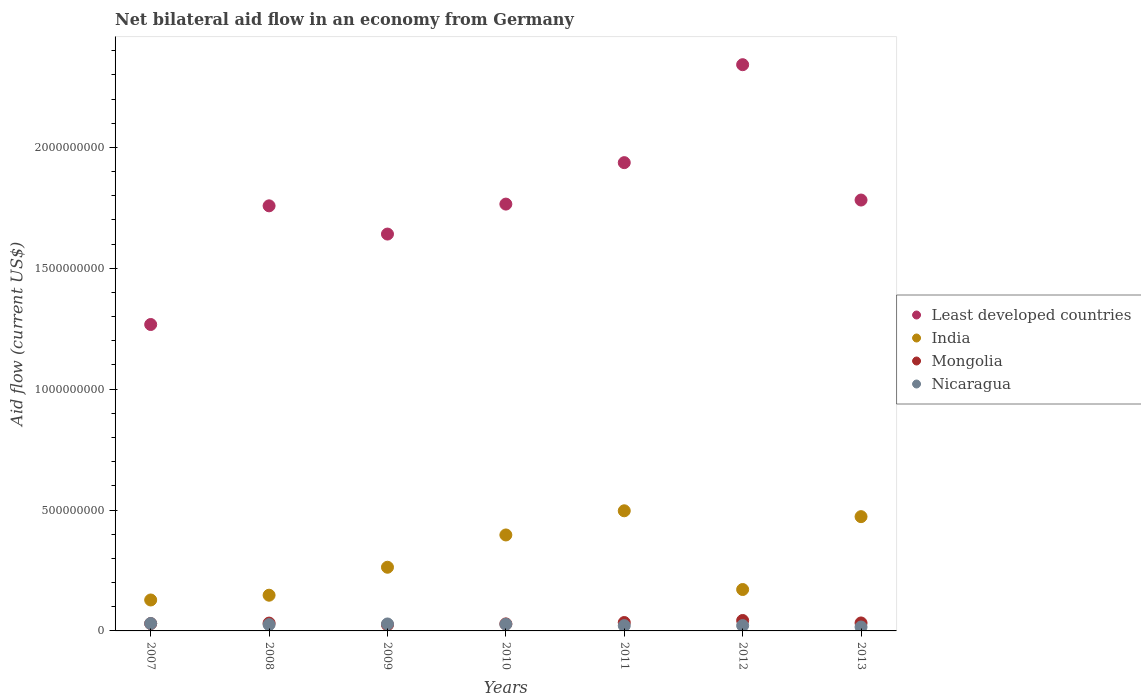How many different coloured dotlines are there?
Make the answer very short. 4. What is the net bilateral aid flow in India in 2010?
Provide a short and direct response. 3.97e+08. Across all years, what is the maximum net bilateral aid flow in India?
Provide a short and direct response. 4.97e+08. Across all years, what is the minimum net bilateral aid flow in Least developed countries?
Keep it short and to the point. 1.27e+09. In which year was the net bilateral aid flow in India minimum?
Ensure brevity in your answer.  2007. What is the total net bilateral aid flow in Mongolia in the graph?
Provide a succinct answer. 2.28e+08. What is the difference between the net bilateral aid flow in India in 2009 and that in 2012?
Offer a terse response. 9.21e+07. What is the difference between the net bilateral aid flow in India in 2010 and the net bilateral aid flow in Mongolia in 2007?
Your answer should be very brief. 3.67e+08. What is the average net bilateral aid flow in Nicaragua per year?
Keep it short and to the point. 2.48e+07. In the year 2013, what is the difference between the net bilateral aid flow in India and net bilateral aid flow in Mongolia?
Your response must be concise. 4.40e+08. What is the ratio of the net bilateral aid flow in Mongolia in 2010 to that in 2011?
Provide a succinct answer. 0.84. Is the net bilateral aid flow in India in 2008 less than that in 2009?
Offer a terse response. Yes. What is the difference between the highest and the second highest net bilateral aid flow in Least developed countries?
Offer a very short reply. 4.05e+08. What is the difference between the highest and the lowest net bilateral aid flow in Least developed countries?
Offer a very short reply. 1.07e+09. In how many years, is the net bilateral aid flow in Mongolia greater than the average net bilateral aid flow in Mongolia taken over all years?
Make the answer very short. 3. Is the sum of the net bilateral aid flow in India in 2007 and 2010 greater than the maximum net bilateral aid flow in Mongolia across all years?
Ensure brevity in your answer.  Yes. Is it the case that in every year, the sum of the net bilateral aid flow in Nicaragua and net bilateral aid flow in Mongolia  is greater than the sum of net bilateral aid flow in India and net bilateral aid flow in Least developed countries?
Provide a short and direct response. No. Is it the case that in every year, the sum of the net bilateral aid flow in India and net bilateral aid flow in Mongolia  is greater than the net bilateral aid flow in Nicaragua?
Make the answer very short. Yes. Is the net bilateral aid flow in India strictly less than the net bilateral aid flow in Nicaragua over the years?
Your answer should be very brief. No. How many dotlines are there?
Your response must be concise. 4. How many years are there in the graph?
Provide a short and direct response. 7. Are the values on the major ticks of Y-axis written in scientific E-notation?
Your response must be concise. No. Does the graph contain any zero values?
Offer a terse response. No. Does the graph contain grids?
Provide a succinct answer. No. How many legend labels are there?
Provide a short and direct response. 4. How are the legend labels stacked?
Your answer should be compact. Vertical. What is the title of the graph?
Keep it short and to the point. Net bilateral aid flow in an economy from Germany. Does "Vanuatu" appear as one of the legend labels in the graph?
Offer a very short reply. No. What is the label or title of the X-axis?
Offer a very short reply. Years. What is the label or title of the Y-axis?
Your response must be concise. Aid flow (current US$). What is the Aid flow (current US$) in Least developed countries in 2007?
Provide a succinct answer. 1.27e+09. What is the Aid flow (current US$) in India in 2007?
Give a very brief answer. 1.28e+08. What is the Aid flow (current US$) in Mongolia in 2007?
Offer a terse response. 3.03e+07. What is the Aid flow (current US$) in Nicaragua in 2007?
Your answer should be very brief. 3.08e+07. What is the Aid flow (current US$) in Least developed countries in 2008?
Ensure brevity in your answer.  1.76e+09. What is the Aid flow (current US$) of India in 2008?
Make the answer very short. 1.48e+08. What is the Aid flow (current US$) of Mongolia in 2008?
Your answer should be compact. 3.24e+07. What is the Aid flow (current US$) in Nicaragua in 2008?
Keep it short and to the point. 2.61e+07. What is the Aid flow (current US$) of Least developed countries in 2009?
Your answer should be compact. 1.64e+09. What is the Aid flow (current US$) in India in 2009?
Give a very brief answer. 2.63e+08. What is the Aid flow (current US$) in Mongolia in 2009?
Offer a very short reply. 2.54e+07. What is the Aid flow (current US$) in Nicaragua in 2009?
Your answer should be compact. 2.88e+07. What is the Aid flow (current US$) in Least developed countries in 2010?
Make the answer very short. 1.77e+09. What is the Aid flow (current US$) of India in 2010?
Offer a very short reply. 3.97e+08. What is the Aid flow (current US$) in Mongolia in 2010?
Your answer should be compact. 2.91e+07. What is the Aid flow (current US$) of Nicaragua in 2010?
Your answer should be compact. 2.77e+07. What is the Aid flow (current US$) in Least developed countries in 2011?
Provide a short and direct response. 1.94e+09. What is the Aid flow (current US$) in India in 2011?
Provide a succinct answer. 4.97e+08. What is the Aid flow (current US$) of Mongolia in 2011?
Your response must be concise. 3.47e+07. What is the Aid flow (current US$) in Nicaragua in 2011?
Provide a succinct answer. 2.18e+07. What is the Aid flow (current US$) of Least developed countries in 2012?
Give a very brief answer. 2.34e+09. What is the Aid flow (current US$) in India in 2012?
Keep it short and to the point. 1.71e+08. What is the Aid flow (current US$) of Mongolia in 2012?
Provide a short and direct response. 4.31e+07. What is the Aid flow (current US$) in Nicaragua in 2012?
Your answer should be very brief. 2.21e+07. What is the Aid flow (current US$) of Least developed countries in 2013?
Your answer should be very brief. 1.78e+09. What is the Aid flow (current US$) of India in 2013?
Ensure brevity in your answer.  4.73e+08. What is the Aid flow (current US$) in Mongolia in 2013?
Ensure brevity in your answer.  3.29e+07. What is the Aid flow (current US$) in Nicaragua in 2013?
Provide a succinct answer. 1.62e+07. Across all years, what is the maximum Aid flow (current US$) in Least developed countries?
Offer a very short reply. 2.34e+09. Across all years, what is the maximum Aid flow (current US$) of India?
Your answer should be compact. 4.97e+08. Across all years, what is the maximum Aid flow (current US$) in Mongolia?
Keep it short and to the point. 4.31e+07. Across all years, what is the maximum Aid flow (current US$) of Nicaragua?
Your response must be concise. 3.08e+07. Across all years, what is the minimum Aid flow (current US$) of Least developed countries?
Your answer should be very brief. 1.27e+09. Across all years, what is the minimum Aid flow (current US$) in India?
Make the answer very short. 1.28e+08. Across all years, what is the minimum Aid flow (current US$) of Mongolia?
Give a very brief answer. 2.54e+07. Across all years, what is the minimum Aid flow (current US$) in Nicaragua?
Your response must be concise. 1.62e+07. What is the total Aid flow (current US$) in Least developed countries in the graph?
Offer a very short reply. 1.25e+1. What is the total Aid flow (current US$) in India in the graph?
Your answer should be very brief. 2.08e+09. What is the total Aid flow (current US$) of Mongolia in the graph?
Your response must be concise. 2.28e+08. What is the total Aid flow (current US$) of Nicaragua in the graph?
Keep it short and to the point. 1.73e+08. What is the difference between the Aid flow (current US$) of Least developed countries in 2007 and that in 2008?
Offer a terse response. -4.91e+08. What is the difference between the Aid flow (current US$) in India in 2007 and that in 2008?
Give a very brief answer. -1.97e+07. What is the difference between the Aid flow (current US$) of Mongolia in 2007 and that in 2008?
Give a very brief answer. -2.05e+06. What is the difference between the Aid flow (current US$) of Nicaragua in 2007 and that in 2008?
Your answer should be compact. 4.67e+06. What is the difference between the Aid flow (current US$) of Least developed countries in 2007 and that in 2009?
Provide a short and direct response. -3.74e+08. What is the difference between the Aid flow (current US$) in India in 2007 and that in 2009?
Your answer should be very brief. -1.35e+08. What is the difference between the Aid flow (current US$) of Mongolia in 2007 and that in 2009?
Give a very brief answer. 4.92e+06. What is the difference between the Aid flow (current US$) in Nicaragua in 2007 and that in 2009?
Provide a short and direct response. 1.95e+06. What is the difference between the Aid flow (current US$) in Least developed countries in 2007 and that in 2010?
Provide a succinct answer. -4.98e+08. What is the difference between the Aid flow (current US$) in India in 2007 and that in 2010?
Your answer should be very brief. -2.69e+08. What is the difference between the Aid flow (current US$) of Mongolia in 2007 and that in 2010?
Your response must be concise. 1.24e+06. What is the difference between the Aid flow (current US$) of Nicaragua in 2007 and that in 2010?
Give a very brief answer. 3.04e+06. What is the difference between the Aid flow (current US$) of Least developed countries in 2007 and that in 2011?
Provide a short and direct response. -6.70e+08. What is the difference between the Aid flow (current US$) of India in 2007 and that in 2011?
Give a very brief answer. -3.69e+08. What is the difference between the Aid flow (current US$) in Mongolia in 2007 and that in 2011?
Your answer should be very brief. -4.41e+06. What is the difference between the Aid flow (current US$) in Nicaragua in 2007 and that in 2011?
Offer a very short reply. 8.94e+06. What is the difference between the Aid flow (current US$) in Least developed countries in 2007 and that in 2012?
Give a very brief answer. -1.07e+09. What is the difference between the Aid flow (current US$) in India in 2007 and that in 2012?
Offer a terse response. -4.33e+07. What is the difference between the Aid flow (current US$) in Mongolia in 2007 and that in 2012?
Ensure brevity in your answer.  -1.28e+07. What is the difference between the Aid flow (current US$) in Nicaragua in 2007 and that in 2012?
Provide a succinct answer. 8.64e+06. What is the difference between the Aid flow (current US$) in Least developed countries in 2007 and that in 2013?
Ensure brevity in your answer.  -5.15e+08. What is the difference between the Aid flow (current US$) of India in 2007 and that in 2013?
Your response must be concise. -3.45e+08. What is the difference between the Aid flow (current US$) in Mongolia in 2007 and that in 2013?
Your response must be concise. -2.62e+06. What is the difference between the Aid flow (current US$) of Nicaragua in 2007 and that in 2013?
Offer a terse response. 1.45e+07. What is the difference between the Aid flow (current US$) in Least developed countries in 2008 and that in 2009?
Keep it short and to the point. 1.17e+08. What is the difference between the Aid flow (current US$) in India in 2008 and that in 2009?
Offer a very short reply. -1.16e+08. What is the difference between the Aid flow (current US$) of Mongolia in 2008 and that in 2009?
Provide a succinct answer. 6.97e+06. What is the difference between the Aid flow (current US$) of Nicaragua in 2008 and that in 2009?
Give a very brief answer. -2.72e+06. What is the difference between the Aid flow (current US$) of Least developed countries in 2008 and that in 2010?
Keep it short and to the point. -7.21e+06. What is the difference between the Aid flow (current US$) of India in 2008 and that in 2010?
Offer a terse response. -2.49e+08. What is the difference between the Aid flow (current US$) in Mongolia in 2008 and that in 2010?
Keep it short and to the point. 3.29e+06. What is the difference between the Aid flow (current US$) in Nicaragua in 2008 and that in 2010?
Provide a short and direct response. -1.63e+06. What is the difference between the Aid flow (current US$) in Least developed countries in 2008 and that in 2011?
Provide a short and direct response. -1.79e+08. What is the difference between the Aid flow (current US$) of India in 2008 and that in 2011?
Your answer should be very brief. -3.49e+08. What is the difference between the Aid flow (current US$) of Mongolia in 2008 and that in 2011?
Offer a terse response. -2.36e+06. What is the difference between the Aid flow (current US$) of Nicaragua in 2008 and that in 2011?
Provide a succinct answer. 4.27e+06. What is the difference between the Aid flow (current US$) of Least developed countries in 2008 and that in 2012?
Give a very brief answer. -5.84e+08. What is the difference between the Aid flow (current US$) of India in 2008 and that in 2012?
Provide a short and direct response. -2.36e+07. What is the difference between the Aid flow (current US$) of Mongolia in 2008 and that in 2012?
Offer a terse response. -1.08e+07. What is the difference between the Aid flow (current US$) in Nicaragua in 2008 and that in 2012?
Ensure brevity in your answer.  3.97e+06. What is the difference between the Aid flow (current US$) in Least developed countries in 2008 and that in 2013?
Make the answer very short. -2.40e+07. What is the difference between the Aid flow (current US$) of India in 2008 and that in 2013?
Offer a terse response. -3.25e+08. What is the difference between the Aid flow (current US$) of Mongolia in 2008 and that in 2013?
Offer a terse response. -5.70e+05. What is the difference between the Aid flow (current US$) of Nicaragua in 2008 and that in 2013?
Your answer should be compact. 9.87e+06. What is the difference between the Aid flow (current US$) in Least developed countries in 2009 and that in 2010?
Give a very brief answer. -1.24e+08. What is the difference between the Aid flow (current US$) in India in 2009 and that in 2010?
Your answer should be very brief. -1.34e+08. What is the difference between the Aid flow (current US$) in Mongolia in 2009 and that in 2010?
Your response must be concise. -3.68e+06. What is the difference between the Aid flow (current US$) of Nicaragua in 2009 and that in 2010?
Provide a succinct answer. 1.09e+06. What is the difference between the Aid flow (current US$) of Least developed countries in 2009 and that in 2011?
Your answer should be very brief. -2.95e+08. What is the difference between the Aid flow (current US$) of India in 2009 and that in 2011?
Ensure brevity in your answer.  -2.34e+08. What is the difference between the Aid flow (current US$) of Mongolia in 2009 and that in 2011?
Keep it short and to the point. -9.33e+06. What is the difference between the Aid flow (current US$) of Nicaragua in 2009 and that in 2011?
Your answer should be very brief. 6.99e+06. What is the difference between the Aid flow (current US$) in Least developed countries in 2009 and that in 2012?
Your answer should be very brief. -7.01e+08. What is the difference between the Aid flow (current US$) in India in 2009 and that in 2012?
Your answer should be very brief. 9.21e+07. What is the difference between the Aid flow (current US$) in Mongolia in 2009 and that in 2012?
Offer a terse response. -1.77e+07. What is the difference between the Aid flow (current US$) in Nicaragua in 2009 and that in 2012?
Make the answer very short. 6.69e+06. What is the difference between the Aid flow (current US$) of Least developed countries in 2009 and that in 2013?
Provide a short and direct response. -1.41e+08. What is the difference between the Aid flow (current US$) in India in 2009 and that in 2013?
Keep it short and to the point. -2.09e+08. What is the difference between the Aid flow (current US$) of Mongolia in 2009 and that in 2013?
Offer a terse response. -7.54e+06. What is the difference between the Aid flow (current US$) of Nicaragua in 2009 and that in 2013?
Ensure brevity in your answer.  1.26e+07. What is the difference between the Aid flow (current US$) of Least developed countries in 2010 and that in 2011?
Keep it short and to the point. -1.71e+08. What is the difference between the Aid flow (current US$) of India in 2010 and that in 2011?
Your response must be concise. -1.00e+08. What is the difference between the Aid flow (current US$) of Mongolia in 2010 and that in 2011?
Offer a very short reply. -5.65e+06. What is the difference between the Aid flow (current US$) in Nicaragua in 2010 and that in 2011?
Offer a very short reply. 5.90e+06. What is the difference between the Aid flow (current US$) of Least developed countries in 2010 and that in 2012?
Offer a very short reply. -5.77e+08. What is the difference between the Aid flow (current US$) of India in 2010 and that in 2012?
Offer a terse response. 2.26e+08. What is the difference between the Aid flow (current US$) in Mongolia in 2010 and that in 2012?
Give a very brief answer. -1.40e+07. What is the difference between the Aid flow (current US$) of Nicaragua in 2010 and that in 2012?
Your response must be concise. 5.60e+06. What is the difference between the Aid flow (current US$) in Least developed countries in 2010 and that in 2013?
Give a very brief answer. -1.68e+07. What is the difference between the Aid flow (current US$) of India in 2010 and that in 2013?
Provide a succinct answer. -7.58e+07. What is the difference between the Aid flow (current US$) in Mongolia in 2010 and that in 2013?
Provide a succinct answer. -3.86e+06. What is the difference between the Aid flow (current US$) of Nicaragua in 2010 and that in 2013?
Your answer should be compact. 1.15e+07. What is the difference between the Aid flow (current US$) in Least developed countries in 2011 and that in 2012?
Provide a short and direct response. -4.05e+08. What is the difference between the Aid flow (current US$) of India in 2011 and that in 2012?
Offer a terse response. 3.26e+08. What is the difference between the Aid flow (current US$) of Mongolia in 2011 and that in 2012?
Offer a terse response. -8.40e+06. What is the difference between the Aid flow (current US$) in Nicaragua in 2011 and that in 2012?
Provide a succinct answer. -3.00e+05. What is the difference between the Aid flow (current US$) in Least developed countries in 2011 and that in 2013?
Give a very brief answer. 1.55e+08. What is the difference between the Aid flow (current US$) of India in 2011 and that in 2013?
Ensure brevity in your answer.  2.42e+07. What is the difference between the Aid flow (current US$) of Mongolia in 2011 and that in 2013?
Your response must be concise. 1.79e+06. What is the difference between the Aid flow (current US$) in Nicaragua in 2011 and that in 2013?
Offer a terse response. 5.60e+06. What is the difference between the Aid flow (current US$) of Least developed countries in 2012 and that in 2013?
Keep it short and to the point. 5.60e+08. What is the difference between the Aid flow (current US$) of India in 2012 and that in 2013?
Keep it short and to the point. -3.01e+08. What is the difference between the Aid flow (current US$) of Mongolia in 2012 and that in 2013?
Keep it short and to the point. 1.02e+07. What is the difference between the Aid flow (current US$) in Nicaragua in 2012 and that in 2013?
Give a very brief answer. 5.90e+06. What is the difference between the Aid flow (current US$) of Least developed countries in 2007 and the Aid flow (current US$) of India in 2008?
Offer a terse response. 1.12e+09. What is the difference between the Aid flow (current US$) in Least developed countries in 2007 and the Aid flow (current US$) in Mongolia in 2008?
Provide a short and direct response. 1.24e+09. What is the difference between the Aid flow (current US$) in Least developed countries in 2007 and the Aid flow (current US$) in Nicaragua in 2008?
Offer a terse response. 1.24e+09. What is the difference between the Aid flow (current US$) of India in 2007 and the Aid flow (current US$) of Mongolia in 2008?
Keep it short and to the point. 9.56e+07. What is the difference between the Aid flow (current US$) in India in 2007 and the Aid flow (current US$) in Nicaragua in 2008?
Provide a short and direct response. 1.02e+08. What is the difference between the Aid flow (current US$) of Mongolia in 2007 and the Aid flow (current US$) of Nicaragua in 2008?
Your answer should be very brief. 4.23e+06. What is the difference between the Aid flow (current US$) in Least developed countries in 2007 and the Aid flow (current US$) in India in 2009?
Provide a short and direct response. 1.00e+09. What is the difference between the Aid flow (current US$) of Least developed countries in 2007 and the Aid flow (current US$) of Mongolia in 2009?
Keep it short and to the point. 1.24e+09. What is the difference between the Aid flow (current US$) of Least developed countries in 2007 and the Aid flow (current US$) of Nicaragua in 2009?
Provide a succinct answer. 1.24e+09. What is the difference between the Aid flow (current US$) in India in 2007 and the Aid flow (current US$) in Mongolia in 2009?
Provide a succinct answer. 1.03e+08. What is the difference between the Aid flow (current US$) of India in 2007 and the Aid flow (current US$) of Nicaragua in 2009?
Provide a succinct answer. 9.92e+07. What is the difference between the Aid flow (current US$) of Mongolia in 2007 and the Aid flow (current US$) of Nicaragua in 2009?
Your answer should be very brief. 1.51e+06. What is the difference between the Aid flow (current US$) of Least developed countries in 2007 and the Aid flow (current US$) of India in 2010?
Give a very brief answer. 8.70e+08. What is the difference between the Aid flow (current US$) in Least developed countries in 2007 and the Aid flow (current US$) in Mongolia in 2010?
Provide a succinct answer. 1.24e+09. What is the difference between the Aid flow (current US$) of Least developed countries in 2007 and the Aid flow (current US$) of Nicaragua in 2010?
Make the answer very short. 1.24e+09. What is the difference between the Aid flow (current US$) of India in 2007 and the Aid flow (current US$) of Mongolia in 2010?
Keep it short and to the point. 9.89e+07. What is the difference between the Aid flow (current US$) in India in 2007 and the Aid flow (current US$) in Nicaragua in 2010?
Give a very brief answer. 1.00e+08. What is the difference between the Aid flow (current US$) of Mongolia in 2007 and the Aid flow (current US$) of Nicaragua in 2010?
Ensure brevity in your answer.  2.60e+06. What is the difference between the Aid flow (current US$) of Least developed countries in 2007 and the Aid flow (current US$) of India in 2011?
Make the answer very short. 7.71e+08. What is the difference between the Aid flow (current US$) in Least developed countries in 2007 and the Aid flow (current US$) in Mongolia in 2011?
Make the answer very short. 1.23e+09. What is the difference between the Aid flow (current US$) of Least developed countries in 2007 and the Aid flow (current US$) of Nicaragua in 2011?
Your answer should be very brief. 1.25e+09. What is the difference between the Aid flow (current US$) of India in 2007 and the Aid flow (current US$) of Mongolia in 2011?
Ensure brevity in your answer.  9.32e+07. What is the difference between the Aid flow (current US$) in India in 2007 and the Aid flow (current US$) in Nicaragua in 2011?
Offer a very short reply. 1.06e+08. What is the difference between the Aid flow (current US$) in Mongolia in 2007 and the Aid flow (current US$) in Nicaragua in 2011?
Your answer should be very brief. 8.50e+06. What is the difference between the Aid flow (current US$) in Least developed countries in 2007 and the Aid flow (current US$) in India in 2012?
Your answer should be compact. 1.10e+09. What is the difference between the Aid flow (current US$) of Least developed countries in 2007 and the Aid flow (current US$) of Mongolia in 2012?
Provide a succinct answer. 1.22e+09. What is the difference between the Aid flow (current US$) in Least developed countries in 2007 and the Aid flow (current US$) in Nicaragua in 2012?
Your answer should be very brief. 1.25e+09. What is the difference between the Aid flow (current US$) in India in 2007 and the Aid flow (current US$) in Mongolia in 2012?
Provide a succinct answer. 8.48e+07. What is the difference between the Aid flow (current US$) in India in 2007 and the Aid flow (current US$) in Nicaragua in 2012?
Your answer should be compact. 1.06e+08. What is the difference between the Aid flow (current US$) in Mongolia in 2007 and the Aid flow (current US$) in Nicaragua in 2012?
Your answer should be compact. 8.20e+06. What is the difference between the Aid flow (current US$) in Least developed countries in 2007 and the Aid flow (current US$) in India in 2013?
Your answer should be compact. 7.95e+08. What is the difference between the Aid flow (current US$) of Least developed countries in 2007 and the Aid flow (current US$) of Mongolia in 2013?
Offer a terse response. 1.23e+09. What is the difference between the Aid flow (current US$) in Least developed countries in 2007 and the Aid flow (current US$) in Nicaragua in 2013?
Ensure brevity in your answer.  1.25e+09. What is the difference between the Aid flow (current US$) of India in 2007 and the Aid flow (current US$) of Mongolia in 2013?
Provide a short and direct response. 9.50e+07. What is the difference between the Aid flow (current US$) in India in 2007 and the Aid flow (current US$) in Nicaragua in 2013?
Give a very brief answer. 1.12e+08. What is the difference between the Aid flow (current US$) in Mongolia in 2007 and the Aid flow (current US$) in Nicaragua in 2013?
Keep it short and to the point. 1.41e+07. What is the difference between the Aid flow (current US$) of Least developed countries in 2008 and the Aid flow (current US$) of India in 2009?
Your response must be concise. 1.49e+09. What is the difference between the Aid flow (current US$) of Least developed countries in 2008 and the Aid flow (current US$) of Mongolia in 2009?
Keep it short and to the point. 1.73e+09. What is the difference between the Aid flow (current US$) of Least developed countries in 2008 and the Aid flow (current US$) of Nicaragua in 2009?
Offer a terse response. 1.73e+09. What is the difference between the Aid flow (current US$) in India in 2008 and the Aid flow (current US$) in Mongolia in 2009?
Give a very brief answer. 1.22e+08. What is the difference between the Aid flow (current US$) in India in 2008 and the Aid flow (current US$) in Nicaragua in 2009?
Provide a succinct answer. 1.19e+08. What is the difference between the Aid flow (current US$) in Mongolia in 2008 and the Aid flow (current US$) in Nicaragua in 2009?
Make the answer very short. 3.56e+06. What is the difference between the Aid flow (current US$) in Least developed countries in 2008 and the Aid flow (current US$) in India in 2010?
Offer a very short reply. 1.36e+09. What is the difference between the Aid flow (current US$) of Least developed countries in 2008 and the Aid flow (current US$) of Mongolia in 2010?
Your answer should be compact. 1.73e+09. What is the difference between the Aid flow (current US$) of Least developed countries in 2008 and the Aid flow (current US$) of Nicaragua in 2010?
Provide a short and direct response. 1.73e+09. What is the difference between the Aid flow (current US$) of India in 2008 and the Aid flow (current US$) of Mongolia in 2010?
Ensure brevity in your answer.  1.19e+08. What is the difference between the Aid flow (current US$) in India in 2008 and the Aid flow (current US$) in Nicaragua in 2010?
Keep it short and to the point. 1.20e+08. What is the difference between the Aid flow (current US$) in Mongolia in 2008 and the Aid flow (current US$) in Nicaragua in 2010?
Provide a succinct answer. 4.65e+06. What is the difference between the Aid flow (current US$) in Least developed countries in 2008 and the Aid flow (current US$) in India in 2011?
Your response must be concise. 1.26e+09. What is the difference between the Aid flow (current US$) in Least developed countries in 2008 and the Aid flow (current US$) in Mongolia in 2011?
Make the answer very short. 1.72e+09. What is the difference between the Aid flow (current US$) in Least developed countries in 2008 and the Aid flow (current US$) in Nicaragua in 2011?
Give a very brief answer. 1.74e+09. What is the difference between the Aid flow (current US$) in India in 2008 and the Aid flow (current US$) in Mongolia in 2011?
Offer a terse response. 1.13e+08. What is the difference between the Aid flow (current US$) of India in 2008 and the Aid flow (current US$) of Nicaragua in 2011?
Give a very brief answer. 1.26e+08. What is the difference between the Aid flow (current US$) in Mongolia in 2008 and the Aid flow (current US$) in Nicaragua in 2011?
Provide a succinct answer. 1.06e+07. What is the difference between the Aid flow (current US$) in Least developed countries in 2008 and the Aid flow (current US$) in India in 2012?
Your response must be concise. 1.59e+09. What is the difference between the Aid flow (current US$) of Least developed countries in 2008 and the Aid flow (current US$) of Mongolia in 2012?
Provide a short and direct response. 1.72e+09. What is the difference between the Aid flow (current US$) of Least developed countries in 2008 and the Aid flow (current US$) of Nicaragua in 2012?
Give a very brief answer. 1.74e+09. What is the difference between the Aid flow (current US$) in India in 2008 and the Aid flow (current US$) in Mongolia in 2012?
Your response must be concise. 1.05e+08. What is the difference between the Aid flow (current US$) in India in 2008 and the Aid flow (current US$) in Nicaragua in 2012?
Your response must be concise. 1.26e+08. What is the difference between the Aid flow (current US$) in Mongolia in 2008 and the Aid flow (current US$) in Nicaragua in 2012?
Offer a terse response. 1.02e+07. What is the difference between the Aid flow (current US$) of Least developed countries in 2008 and the Aid flow (current US$) of India in 2013?
Offer a terse response. 1.29e+09. What is the difference between the Aid flow (current US$) of Least developed countries in 2008 and the Aid flow (current US$) of Mongolia in 2013?
Offer a very short reply. 1.73e+09. What is the difference between the Aid flow (current US$) in Least developed countries in 2008 and the Aid flow (current US$) in Nicaragua in 2013?
Make the answer very short. 1.74e+09. What is the difference between the Aid flow (current US$) in India in 2008 and the Aid flow (current US$) in Mongolia in 2013?
Ensure brevity in your answer.  1.15e+08. What is the difference between the Aid flow (current US$) of India in 2008 and the Aid flow (current US$) of Nicaragua in 2013?
Make the answer very short. 1.31e+08. What is the difference between the Aid flow (current US$) in Mongolia in 2008 and the Aid flow (current US$) in Nicaragua in 2013?
Provide a short and direct response. 1.62e+07. What is the difference between the Aid flow (current US$) in Least developed countries in 2009 and the Aid flow (current US$) in India in 2010?
Ensure brevity in your answer.  1.24e+09. What is the difference between the Aid flow (current US$) of Least developed countries in 2009 and the Aid flow (current US$) of Mongolia in 2010?
Make the answer very short. 1.61e+09. What is the difference between the Aid flow (current US$) of Least developed countries in 2009 and the Aid flow (current US$) of Nicaragua in 2010?
Make the answer very short. 1.61e+09. What is the difference between the Aid flow (current US$) in India in 2009 and the Aid flow (current US$) in Mongolia in 2010?
Your answer should be very brief. 2.34e+08. What is the difference between the Aid flow (current US$) of India in 2009 and the Aid flow (current US$) of Nicaragua in 2010?
Keep it short and to the point. 2.36e+08. What is the difference between the Aid flow (current US$) in Mongolia in 2009 and the Aid flow (current US$) in Nicaragua in 2010?
Your answer should be compact. -2.32e+06. What is the difference between the Aid flow (current US$) of Least developed countries in 2009 and the Aid flow (current US$) of India in 2011?
Give a very brief answer. 1.14e+09. What is the difference between the Aid flow (current US$) of Least developed countries in 2009 and the Aid flow (current US$) of Mongolia in 2011?
Your response must be concise. 1.61e+09. What is the difference between the Aid flow (current US$) in Least developed countries in 2009 and the Aid flow (current US$) in Nicaragua in 2011?
Keep it short and to the point. 1.62e+09. What is the difference between the Aid flow (current US$) of India in 2009 and the Aid flow (current US$) of Mongolia in 2011?
Make the answer very short. 2.29e+08. What is the difference between the Aid flow (current US$) in India in 2009 and the Aid flow (current US$) in Nicaragua in 2011?
Offer a terse response. 2.42e+08. What is the difference between the Aid flow (current US$) in Mongolia in 2009 and the Aid flow (current US$) in Nicaragua in 2011?
Your response must be concise. 3.58e+06. What is the difference between the Aid flow (current US$) in Least developed countries in 2009 and the Aid flow (current US$) in India in 2012?
Ensure brevity in your answer.  1.47e+09. What is the difference between the Aid flow (current US$) in Least developed countries in 2009 and the Aid flow (current US$) in Mongolia in 2012?
Keep it short and to the point. 1.60e+09. What is the difference between the Aid flow (current US$) of Least developed countries in 2009 and the Aid flow (current US$) of Nicaragua in 2012?
Give a very brief answer. 1.62e+09. What is the difference between the Aid flow (current US$) in India in 2009 and the Aid flow (current US$) in Mongolia in 2012?
Provide a succinct answer. 2.20e+08. What is the difference between the Aid flow (current US$) in India in 2009 and the Aid flow (current US$) in Nicaragua in 2012?
Ensure brevity in your answer.  2.41e+08. What is the difference between the Aid flow (current US$) in Mongolia in 2009 and the Aid flow (current US$) in Nicaragua in 2012?
Your answer should be very brief. 3.28e+06. What is the difference between the Aid flow (current US$) of Least developed countries in 2009 and the Aid flow (current US$) of India in 2013?
Your response must be concise. 1.17e+09. What is the difference between the Aid flow (current US$) of Least developed countries in 2009 and the Aid flow (current US$) of Mongolia in 2013?
Ensure brevity in your answer.  1.61e+09. What is the difference between the Aid flow (current US$) of Least developed countries in 2009 and the Aid flow (current US$) of Nicaragua in 2013?
Keep it short and to the point. 1.63e+09. What is the difference between the Aid flow (current US$) in India in 2009 and the Aid flow (current US$) in Mongolia in 2013?
Your answer should be compact. 2.30e+08. What is the difference between the Aid flow (current US$) in India in 2009 and the Aid flow (current US$) in Nicaragua in 2013?
Offer a terse response. 2.47e+08. What is the difference between the Aid flow (current US$) of Mongolia in 2009 and the Aid flow (current US$) of Nicaragua in 2013?
Your answer should be compact. 9.18e+06. What is the difference between the Aid flow (current US$) of Least developed countries in 2010 and the Aid flow (current US$) of India in 2011?
Provide a succinct answer. 1.27e+09. What is the difference between the Aid flow (current US$) in Least developed countries in 2010 and the Aid flow (current US$) in Mongolia in 2011?
Your answer should be very brief. 1.73e+09. What is the difference between the Aid flow (current US$) in Least developed countries in 2010 and the Aid flow (current US$) in Nicaragua in 2011?
Offer a very short reply. 1.74e+09. What is the difference between the Aid flow (current US$) of India in 2010 and the Aid flow (current US$) of Mongolia in 2011?
Offer a very short reply. 3.62e+08. What is the difference between the Aid flow (current US$) in India in 2010 and the Aid flow (current US$) in Nicaragua in 2011?
Make the answer very short. 3.75e+08. What is the difference between the Aid flow (current US$) in Mongolia in 2010 and the Aid flow (current US$) in Nicaragua in 2011?
Your response must be concise. 7.26e+06. What is the difference between the Aid flow (current US$) of Least developed countries in 2010 and the Aid flow (current US$) of India in 2012?
Give a very brief answer. 1.59e+09. What is the difference between the Aid flow (current US$) of Least developed countries in 2010 and the Aid flow (current US$) of Mongolia in 2012?
Your answer should be compact. 1.72e+09. What is the difference between the Aid flow (current US$) of Least developed countries in 2010 and the Aid flow (current US$) of Nicaragua in 2012?
Your answer should be very brief. 1.74e+09. What is the difference between the Aid flow (current US$) in India in 2010 and the Aid flow (current US$) in Mongolia in 2012?
Offer a terse response. 3.54e+08. What is the difference between the Aid flow (current US$) of India in 2010 and the Aid flow (current US$) of Nicaragua in 2012?
Provide a succinct answer. 3.75e+08. What is the difference between the Aid flow (current US$) of Mongolia in 2010 and the Aid flow (current US$) of Nicaragua in 2012?
Your answer should be compact. 6.96e+06. What is the difference between the Aid flow (current US$) of Least developed countries in 2010 and the Aid flow (current US$) of India in 2013?
Ensure brevity in your answer.  1.29e+09. What is the difference between the Aid flow (current US$) in Least developed countries in 2010 and the Aid flow (current US$) in Mongolia in 2013?
Offer a very short reply. 1.73e+09. What is the difference between the Aid flow (current US$) in Least developed countries in 2010 and the Aid flow (current US$) in Nicaragua in 2013?
Offer a terse response. 1.75e+09. What is the difference between the Aid flow (current US$) of India in 2010 and the Aid flow (current US$) of Mongolia in 2013?
Provide a succinct answer. 3.64e+08. What is the difference between the Aid flow (current US$) of India in 2010 and the Aid flow (current US$) of Nicaragua in 2013?
Ensure brevity in your answer.  3.81e+08. What is the difference between the Aid flow (current US$) of Mongolia in 2010 and the Aid flow (current US$) of Nicaragua in 2013?
Your answer should be compact. 1.29e+07. What is the difference between the Aid flow (current US$) of Least developed countries in 2011 and the Aid flow (current US$) of India in 2012?
Provide a succinct answer. 1.77e+09. What is the difference between the Aid flow (current US$) of Least developed countries in 2011 and the Aid flow (current US$) of Mongolia in 2012?
Your answer should be compact. 1.89e+09. What is the difference between the Aid flow (current US$) in Least developed countries in 2011 and the Aid flow (current US$) in Nicaragua in 2012?
Provide a succinct answer. 1.91e+09. What is the difference between the Aid flow (current US$) in India in 2011 and the Aid flow (current US$) in Mongolia in 2012?
Your answer should be very brief. 4.54e+08. What is the difference between the Aid flow (current US$) of India in 2011 and the Aid flow (current US$) of Nicaragua in 2012?
Provide a succinct answer. 4.75e+08. What is the difference between the Aid flow (current US$) of Mongolia in 2011 and the Aid flow (current US$) of Nicaragua in 2012?
Your answer should be very brief. 1.26e+07. What is the difference between the Aid flow (current US$) in Least developed countries in 2011 and the Aid flow (current US$) in India in 2013?
Provide a short and direct response. 1.46e+09. What is the difference between the Aid flow (current US$) of Least developed countries in 2011 and the Aid flow (current US$) of Mongolia in 2013?
Offer a very short reply. 1.90e+09. What is the difference between the Aid flow (current US$) in Least developed countries in 2011 and the Aid flow (current US$) in Nicaragua in 2013?
Keep it short and to the point. 1.92e+09. What is the difference between the Aid flow (current US$) in India in 2011 and the Aid flow (current US$) in Mongolia in 2013?
Keep it short and to the point. 4.64e+08. What is the difference between the Aid flow (current US$) in India in 2011 and the Aid flow (current US$) in Nicaragua in 2013?
Give a very brief answer. 4.81e+08. What is the difference between the Aid flow (current US$) in Mongolia in 2011 and the Aid flow (current US$) in Nicaragua in 2013?
Provide a short and direct response. 1.85e+07. What is the difference between the Aid flow (current US$) in Least developed countries in 2012 and the Aid flow (current US$) in India in 2013?
Make the answer very short. 1.87e+09. What is the difference between the Aid flow (current US$) of Least developed countries in 2012 and the Aid flow (current US$) of Mongolia in 2013?
Your response must be concise. 2.31e+09. What is the difference between the Aid flow (current US$) in Least developed countries in 2012 and the Aid flow (current US$) in Nicaragua in 2013?
Make the answer very short. 2.33e+09. What is the difference between the Aid flow (current US$) of India in 2012 and the Aid flow (current US$) of Mongolia in 2013?
Your answer should be very brief. 1.38e+08. What is the difference between the Aid flow (current US$) of India in 2012 and the Aid flow (current US$) of Nicaragua in 2013?
Your answer should be compact. 1.55e+08. What is the difference between the Aid flow (current US$) of Mongolia in 2012 and the Aid flow (current US$) of Nicaragua in 2013?
Keep it short and to the point. 2.69e+07. What is the average Aid flow (current US$) of Least developed countries per year?
Your answer should be very brief. 1.78e+09. What is the average Aid flow (current US$) in India per year?
Offer a very short reply. 2.97e+08. What is the average Aid flow (current US$) in Mongolia per year?
Keep it short and to the point. 3.26e+07. What is the average Aid flow (current US$) of Nicaragua per year?
Your answer should be compact. 2.48e+07. In the year 2007, what is the difference between the Aid flow (current US$) of Least developed countries and Aid flow (current US$) of India?
Your response must be concise. 1.14e+09. In the year 2007, what is the difference between the Aid flow (current US$) in Least developed countries and Aid flow (current US$) in Mongolia?
Offer a very short reply. 1.24e+09. In the year 2007, what is the difference between the Aid flow (current US$) in Least developed countries and Aid flow (current US$) in Nicaragua?
Give a very brief answer. 1.24e+09. In the year 2007, what is the difference between the Aid flow (current US$) in India and Aid flow (current US$) in Mongolia?
Offer a terse response. 9.77e+07. In the year 2007, what is the difference between the Aid flow (current US$) in India and Aid flow (current US$) in Nicaragua?
Your answer should be very brief. 9.72e+07. In the year 2007, what is the difference between the Aid flow (current US$) of Mongolia and Aid flow (current US$) of Nicaragua?
Give a very brief answer. -4.40e+05. In the year 2008, what is the difference between the Aid flow (current US$) in Least developed countries and Aid flow (current US$) in India?
Provide a short and direct response. 1.61e+09. In the year 2008, what is the difference between the Aid flow (current US$) in Least developed countries and Aid flow (current US$) in Mongolia?
Your response must be concise. 1.73e+09. In the year 2008, what is the difference between the Aid flow (current US$) of Least developed countries and Aid flow (current US$) of Nicaragua?
Give a very brief answer. 1.73e+09. In the year 2008, what is the difference between the Aid flow (current US$) of India and Aid flow (current US$) of Mongolia?
Your answer should be very brief. 1.15e+08. In the year 2008, what is the difference between the Aid flow (current US$) of India and Aid flow (current US$) of Nicaragua?
Provide a short and direct response. 1.22e+08. In the year 2008, what is the difference between the Aid flow (current US$) in Mongolia and Aid flow (current US$) in Nicaragua?
Provide a short and direct response. 6.28e+06. In the year 2009, what is the difference between the Aid flow (current US$) of Least developed countries and Aid flow (current US$) of India?
Keep it short and to the point. 1.38e+09. In the year 2009, what is the difference between the Aid flow (current US$) of Least developed countries and Aid flow (current US$) of Mongolia?
Provide a succinct answer. 1.62e+09. In the year 2009, what is the difference between the Aid flow (current US$) of Least developed countries and Aid flow (current US$) of Nicaragua?
Offer a very short reply. 1.61e+09. In the year 2009, what is the difference between the Aid flow (current US$) in India and Aid flow (current US$) in Mongolia?
Provide a short and direct response. 2.38e+08. In the year 2009, what is the difference between the Aid flow (current US$) in India and Aid flow (current US$) in Nicaragua?
Keep it short and to the point. 2.35e+08. In the year 2009, what is the difference between the Aid flow (current US$) of Mongolia and Aid flow (current US$) of Nicaragua?
Your answer should be very brief. -3.41e+06. In the year 2010, what is the difference between the Aid flow (current US$) in Least developed countries and Aid flow (current US$) in India?
Offer a very short reply. 1.37e+09. In the year 2010, what is the difference between the Aid flow (current US$) of Least developed countries and Aid flow (current US$) of Mongolia?
Offer a terse response. 1.74e+09. In the year 2010, what is the difference between the Aid flow (current US$) in Least developed countries and Aid flow (current US$) in Nicaragua?
Your response must be concise. 1.74e+09. In the year 2010, what is the difference between the Aid flow (current US$) of India and Aid flow (current US$) of Mongolia?
Your response must be concise. 3.68e+08. In the year 2010, what is the difference between the Aid flow (current US$) of India and Aid flow (current US$) of Nicaragua?
Give a very brief answer. 3.69e+08. In the year 2010, what is the difference between the Aid flow (current US$) of Mongolia and Aid flow (current US$) of Nicaragua?
Provide a short and direct response. 1.36e+06. In the year 2011, what is the difference between the Aid flow (current US$) in Least developed countries and Aid flow (current US$) in India?
Your response must be concise. 1.44e+09. In the year 2011, what is the difference between the Aid flow (current US$) of Least developed countries and Aid flow (current US$) of Mongolia?
Give a very brief answer. 1.90e+09. In the year 2011, what is the difference between the Aid flow (current US$) of Least developed countries and Aid flow (current US$) of Nicaragua?
Provide a short and direct response. 1.92e+09. In the year 2011, what is the difference between the Aid flow (current US$) in India and Aid flow (current US$) in Mongolia?
Ensure brevity in your answer.  4.62e+08. In the year 2011, what is the difference between the Aid flow (current US$) of India and Aid flow (current US$) of Nicaragua?
Make the answer very short. 4.75e+08. In the year 2011, what is the difference between the Aid flow (current US$) of Mongolia and Aid flow (current US$) of Nicaragua?
Offer a terse response. 1.29e+07. In the year 2012, what is the difference between the Aid flow (current US$) of Least developed countries and Aid flow (current US$) of India?
Your response must be concise. 2.17e+09. In the year 2012, what is the difference between the Aid flow (current US$) in Least developed countries and Aid flow (current US$) in Mongolia?
Keep it short and to the point. 2.30e+09. In the year 2012, what is the difference between the Aid flow (current US$) of Least developed countries and Aid flow (current US$) of Nicaragua?
Ensure brevity in your answer.  2.32e+09. In the year 2012, what is the difference between the Aid flow (current US$) of India and Aid flow (current US$) of Mongolia?
Your response must be concise. 1.28e+08. In the year 2012, what is the difference between the Aid flow (current US$) in India and Aid flow (current US$) in Nicaragua?
Make the answer very short. 1.49e+08. In the year 2012, what is the difference between the Aid flow (current US$) of Mongolia and Aid flow (current US$) of Nicaragua?
Ensure brevity in your answer.  2.10e+07. In the year 2013, what is the difference between the Aid flow (current US$) in Least developed countries and Aid flow (current US$) in India?
Make the answer very short. 1.31e+09. In the year 2013, what is the difference between the Aid flow (current US$) in Least developed countries and Aid flow (current US$) in Mongolia?
Provide a succinct answer. 1.75e+09. In the year 2013, what is the difference between the Aid flow (current US$) of Least developed countries and Aid flow (current US$) of Nicaragua?
Offer a very short reply. 1.77e+09. In the year 2013, what is the difference between the Aid flow (current US$) of India and Aid flow (current US$) of Mongolia?
Your answer should be very brief. 4.40e+08. In the year 2013, what is the difference between the Aid flow (current US$) of India and Aid flow (current US$) of Nicaragua?
Your response must be concise. 4.56e+08. In the year 2013, what is the difference between the Aid flow (current US$) of Mongolia and Aid flow (current US$) of Nicaragua?
Your answer should be compact. 1.67e+07. What is the ratio of the Aid flow (current US$) in Least developed countries in 2007 to that in 2008?
Ensure brevity in your answer.  0.72. What is the ratio of the Aid flow (current US$) in India in 2007 to that in 2008?
Make the answer very short. 0.87. What is the ratio of the Aid flow (current US$) in Mongolia in 2007 to that in 2008?
Your answer should be compact. 0.94. What is the ratio of the Aid flow (current US$) of Nicaragua in 2007 to that in 2008?
Give a very brief answer. 1.18. What is the ratio of the Aid flow (current US$) in Least developed countries in 2007 to that in 2009?
Offer a terse response. 0.77. What is the ratio of the Aid flow (current US$) of India in 2007 to that in 2009?
Keep it short and to the point. 0.49. What is the ratio of the Aid flow (current US$) of Mongolia in 2007 to that in 2009?
Provide a succinct answer. 1.19. What is the ratio of the Aid flow (current US$) of Nicaragua in 2007 to that in 2009?
Offer a very short reply. 1.07. What is the ratio of the Aid flow (current US$) of Least developed countries in 2007 to that in 2010?
Your answer should be very brief. 0.72. What is the ratio of the Aid flow (current US$) in India in 2007 to that in 2010?
Keep it short and to the point. 0.32. What is the ratio of the Aid flow (current US$) of Mongolia in 2007 to that in 2010?
Make the answer very short. 1.04. What is the ratio of the Aid flow (current US$) in Nicaragua in 2007 to that in 2010?
Provide a short and direct response. 1.11. What is the ratio of the Aid flow (current US$) of Least developed countries in 2007 to that in 2011?
Provide a short and direct response. 0.65. What is the ratio of the Aid flow (current US$) in India in 2007 to that in 2011?
Offer a terse response. 0.26. What is the ratio of the Aid flow (current US$) of Mongolia in 2007 to that in 2011?
Make the answer very short. 0.87. What is the ratio of the Aid flow (current US$) in Nicaragua in 2007 to that in 2011?
Keep it short and to the point. 1.41. What is the ratio of the Aid flow (current US$) of Least developed countries in 2007 to that in 2012?
Make the answer very short. 0.54. What is the ratio of the Aid flow (current US$) of India in 2007 to that in 2012?
Your response must be concise. 0.75. What is the ratio of the Aid flow (current US$) of Mongolia in 2007 to that in 2012?
Provide a succinct answer. 0.7. What is the ratio of the Aid flow (current US$) in Nicaragua in 2007 to that in 2012?
Provide a short and direct response. 1.39. What is the ratio of the Aid flow (current US$) of Least developed countries in 2007 to that in 2013?
Provide a short and direct response. 0.71. What is the ratio of the Aid flow (current US$) of India in 2007 to that in 2013?
Your answer should be very brief. 0.27. What is the ratio of the Aid flow (current US$) in Mongolia in 2007 to that in 2013?
Keep it short and to the point. 0.92. What is the ratio of the Aid flow (current US$) of Nicaragua in 2007 to that in 2013?
Keep it short and to the point. 1.9. What is the ratio of the Aid flow (current US$) of Least developed countries in 2008 to that in 2009?
Ensure brevity in your answer.  1.07. What is the ratio of the Aid flow (current US$) of India in 2008 to that in 2009?
Make the answer very short. 0.56. What is the ratio of the Aid flow (current US$) in Mongolia in 2008 to that in 2009?
Make the answer very short. 1.27. What is the ratio of the Aid flow (current US$) in Nicaragua in 2008 to that in 2009?
Your response must be concise. 0.91. What is the ratio of the Aid flow (current US$) of Least developed countries in 2008 to that in 2010?
Keep it short and to the point. 1. What is the ratio of the Aid flow (current US$) in India in 2008 to that in 2010?
Your answer should be compact. 0.37. What is the ratio of the Aid flow (current US$) of Mongolia in 2008 to that in 2010?
Provide a succinct answer. 1.11. What is the ratio of the Aid flow (current US$) in Least developed countries in 2008 to that in 2011?
Offer a very short reply. 0.91. What is the ratio of the Aid flow (current US$) of India in 2008 to that in 2011?
Make the answer very short. 0.3. What is the ratio of the Aid flow (current US$) in Mongolia in 2008 to that in 2011?
Keep it short and to the point. 0.93. What is the ratio of the Aid flow (current US$) of Nicaragua in 2008 to that in 2011?
Your answer should be very brief. 1.2. What is the ratio of the Aid flow (current US$) of Least developed countries in 2008 to that in 2012?
Your answer should be very brief. 0.75. What is the ratio of the Aid flow (current US$) of India in 2008 to that in 2012?
Your response must be concise. 0.86. What is the ratio of the Aid flow (current US$) of Mongolia in 2008 to that in 2012?
Offer a very short reply. 0.75. What is the ratio of the Aid flow (current US$) of Nicaragua in 2008 to that in 2012?
Your answer should be very brief. 1.18. What is the ratio of the Aid flow (current US$) in Least developed countries in 2008 to that in 2013?
Provide a short and direct response. 0.99. What is the ratio of the Aid flow (current US$) of India in 2008 to that in 2013?
Offer a terse response. 0.31. What is the ratio of the Aid flow (current US$) in Mongolia in 2008 to that in 2013?
Offer a terse response. 0.98. What is the ratio of the Aid flow (current US$) in Nicaragua in 2008 to that in 2013?
Keep it short and to the point. 1.61. What is the ratio of the Aid flow (current US$) of Least developed countries in 2009 to that in 2010?
Ensure brevity in your answer.  0.93. What is the ratio of the Aid flow (current US$) of India in 2009 to that in 2010?
Keep it short and to the point. 0.66. What is the ratio of the Aid flow (current US$) of Mongolia in 2009 to that in 2010?
Ensure brevity in your answer.  0.87. What is the ratio of the Aid flow (current US$) of Nicaragua in 2009 to that in 2010?
Provide a short and direct response. 1.04. What is the ratio of the Aid flow (current US$) of Least developed countries in 2009 to that in 2011?
Keep it short and to the point. 0.85. What is the ratio of the Aid flow (current US$) in India in 2009 to that in 2011?
Offer a very short reply. 0.53. What is the ratio of the Aid flow (current US$) in Mongolia in 2009 to that in 2011?
Ensure brevity in your answer.  0.73. What is the ratio of the Aid flow (current US$) in Nicaragua in 2009 to that in 2011?
Your answer should be very brief. 1.32. What is the ratio of the Aid flow (current US$) in Least developed countries in 2009 to that in 2012?
Offer a very short reply. 0.7. What is the ratio of the Aid flow (current US$) of India in 2009 to that in 2012?
Offer a terse response. 1.54. What is the ratio of the Aid flow (current US$) in Mongolia in 2009 to that in 2012?
Offer a very short reply. 0.59. What is the ratio of the Aid flow (current US$) of Nicaragua in 2009 to that in 2012?
Your answer should be very brief. 1.3. What is the ratio of the Aid flow (current US$) of Least developed countries in 2009 to that in 2013?
Your response must be concise. 0.92. What is the ratio of the Aid flow (current US$) of India in 2009 to that in 2013?
Your response must be concise. 0.56. What is the ratio of the Aid flow (current US$) of Mongolia in 2009 to that in 2013?
Keep it short and to the point. 0.77. What is the ratio of the Aid flow (current US$) of Nicaragua in 2009 to that in 2013?
Your answer should be very brief. 1.78. What is the ratio of the Aid flow (current US$) in Least developed countries in 2010 to that in 2011?
Your answer should be compact. 0.91. What is the ratio of the Aid flow (current US$) in India in 2010 to that in 2011?
Make the answer very short. 0.8. What is the ratio of the Aid flow (current US$) in Mongolia in 2010 to that in 2011?
Offer a terse response. 0.84. What is the ratio of the Aid flow (current US$) in Nicaragua in 2010 to that in 2011?
Ensure brevity in your answer.  1.27. What is the ratio of the Aid flow (current US$) in Least developed countries in 2010 to that in 2012?
Keep it short and to the point. 0.75. What is the ratio of the Aid flow (current US$) of India in 2010 to that in 2012?
Your answer should be compact. 2.32. What is the ratio of the Aid flow (current US$) of Mongolia in 2010 to that in 2012?
Keep it short and to the point. 0.67. What is the ratio of the Aid flow (current US$) in Nicaragua in 2010 to that in 2012?
Your answer should be compact. 1.25. What is the ratio of the Aid flow (current US$) in Least developed countries in 2010 to that in 2013?
Offer a terse response. 0.99. What is the ratio of the Aid flow (current US$) in India in 2010 to that in 2013?
Your response must be concise. 0.84. What is the ratio of the Aid flow (current US$) in Mongolia in 2010 to that in 2013?
Give a very brief answer. 0.88. What is the ratio of the Aid flow (current US$) in Nicaragua in 2010 to that in 2013?
Provide a short and direct response. 1.71. What is the ratio of the Aid flow (current US$) in Least developed countries in 2011 to that in 2012?
Ensure brevity in your answer.  0.83. What is the ratio of the Aid flow (current US$) in India in 2011 to that in 2012?
Provide a short and direct response. 2.9. What is the ratio of the Aid flow (current US$) of Mongolia in 2011 to that in 2012?
Provide a succinct answer. 0.81. What is the ratio of the Aid flow (current US$) of Nicaragua in 2011 to that in 2012?
Your response must be concise. 0.99. What is the ratio of the Aid flow (current US$) in Least developed countries in 2011 to that in 2013?
Provide a short and direct response. 1.09. What is the ratio of the Aid flow (current US$) of India in 2011 to that in 2013?
Ensure brevity in your answer.  1.05. What is the ratio of the Aid flow (current US$) of Mongolia in 2011 to that in 2013?
Provide a short and direct response. 1.05. What is the ratio of the Aid flow (current US$) of Nicaragua in 2011 to that in 2013?
Make the answer very short. 1.35. What is the ratio of the Aid flow (current US$) in Least developed countries in 2012 to that in 2013?
Provide a succinct answer. 1.31. What is the ratio of the Aid flow (current US$) of India in 2012 to that in 2013?
Your answer should be compact. 0.36. What is the ratio of the Aid flow (current US$) in Mongolia in 2012 to that in 2013?
Provide a short and direct response. 1.31. What is the ratio of the Aid flow (current US$) of Nicaragua in 2012 to that in 2013?
Your response must be concise. 1.36. What is the difference between the highest and the second highest Aid flow (current US$) in Least developed countries?
Offer a very short reply. 4.05e+08. What is the difference between the highest and the second highest Aid flow (current US$) of India?
Provide a succinct answer. 2.42e+07. What is the difference between the highest and the second highest Aid flow (current US$) of Mongolia?
Make the answer very short. 8.40e+06. What is the difference between the highest and the second highest Aid flow (current US$) of Nicaragua?
Provide a succinct answer. 1.95e+06. What is the difference between the highest and the lowest Aid flow (current US$) of Least developed countries?
Offer a terse response. 1.07e+09. What is the difference between the highest and the lowest Aid flow (current US$) of India?
Give a very brief answer. 3.69e+08. What is the difference between the highest and the lowest Aid flow (current US$) in Mongolia?
Give a very brief answer. 1.77e+07. What is the difference between the highest and the lowest Aid flow (current US$) in Nicaragua?
Offer a very short reply. 1.45e+07. 